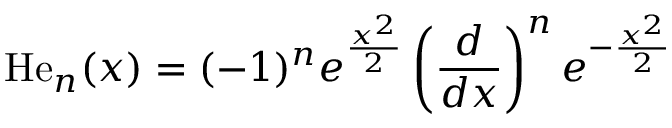<formula> <loc_0><loc_0><loc_500><loc_500>H e _ { n } ( x ) = ( - 1 ) ^ { n } e ^ { \frac { x ^ { 2 } } { 2 } } \left ( { \frac { d } { d x } } \right ) ^ { n } e ^ { - { \frac { x ^ { 2 } } { 2 } } }</formula> 